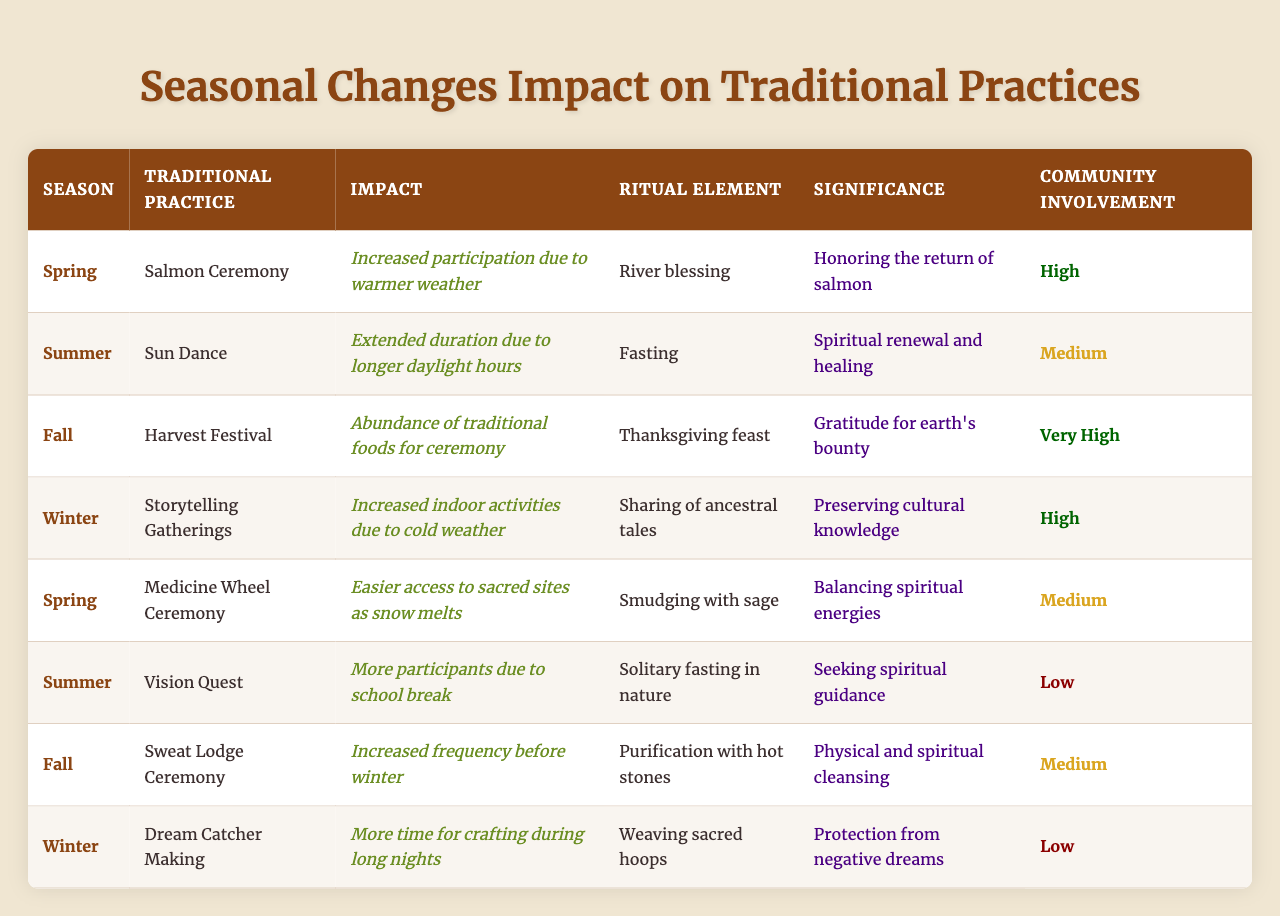What traditional practice takes place in Fall? According to the table, the traditional practice that takes place in Fall is the Harvest Festival.
Answer: Harvest Festival Which season has the highest community involvement? The Fall season has the highest community involvement as indicated by the "Very High" designation in the Community Involvement column.
Answer: Fall What is the significance of the Sweat Lodge Ceremony? The significance of the Sweat Lodge Ceremony is physical and spiritual cleansing, as described in the Significance column.
Answer: Physical and spiritual cleansing How does the impact of the Salmon Ceremony relate to community involvement? The Salmon Ceremony has a high participation due to warmer weather, which reflects a high level of community involvement during Spring.
Answer: High participation and involvement How many traditional practices occur in Winter? From the table, there are two traditional practices occurring in Winter: Storytelling Gatherings and Dream Catcher Making.
Answer: Two What is the impact of the Vision Quest during Summer compared to other summer practices? The Vision Quest has less community involvement as it has a low participation rate, while the Sun Dance sees medium involvement and extends due to longer daylight.
Answer: Less involvement in Vision Quest Are there any Spring practices that involve keeping balance? Yes, the Medicine Wheel Ceremony in Spring involves smudging with sage, which is used for balancing spiritual energies.
Answer: Yes What season has the greatest abundance for ceremonies? Fall has an abundance of traditional foods for the Harvest Festival, indicating it is the season with the greatest abundance for ceremonies.
Answer: Fall Is there a traditional practice that involves crafting during Winter? Yes, in Winter, there is the practice of Dream Catcher Making, which involves crafting.
Answer: Yes Which season shows increased indoor activities due to weather conditions? Winter shows increased indoor activities due to cold weather, as noted in the impact of the Storytelling Gatherings.
Answer: Winter 